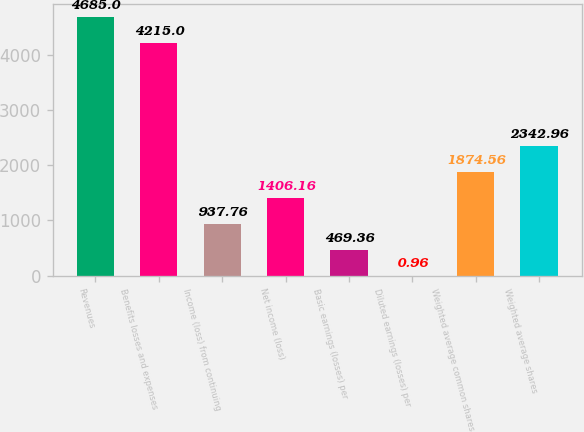Convert chart. <chart><loc_0><loc_0><loc_500><loc_500><bar_chart><fcel>Revenues<fcel>Benefits losses and expenses<fcel>Income (loss) from continuing<fcel>Net income (loss)<fcel>Basic earnings (losses) per<fcel>Diluted earnings (losses) per<fcel>Weighted average common shares<fcel>Weighted average shares<nl><fcel>4685<fcel>4215<fcel>937.76<fcel>1406.16<fcel>469.36<fcel>0.96<fcel>1874.56<fcel>2342.96<nl></chart> 